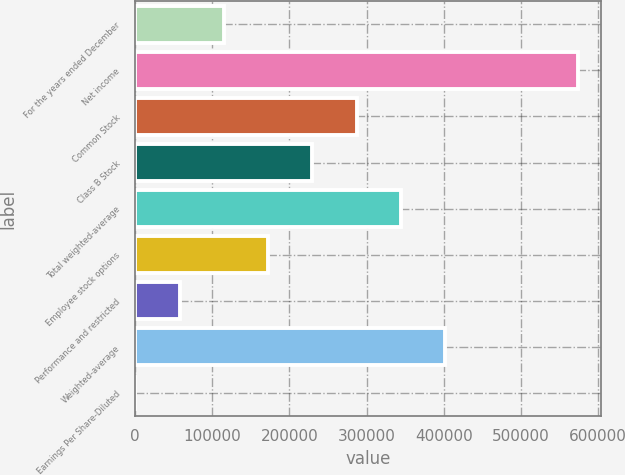Convert chart. <chart><loc_0><loc_0><loc_500><loc_500><bar_chart><fcel>For the years ended December<fcel>Net income<fcel>Common Stock<fcel>Class B Stock<fcel>Total weighted-average<fcel>Employee stock options<fcel>Performance and restricted<fcel>Weighted-average<fcel>Earnings Per Share-Diluted<nl><fcel>114929<fcel>574637<fcel>287320<fcel>229856<fcel>344783<fcel>172393<fcel>57465.7<fcel>402247<fcel>2.24<nl></chart> 